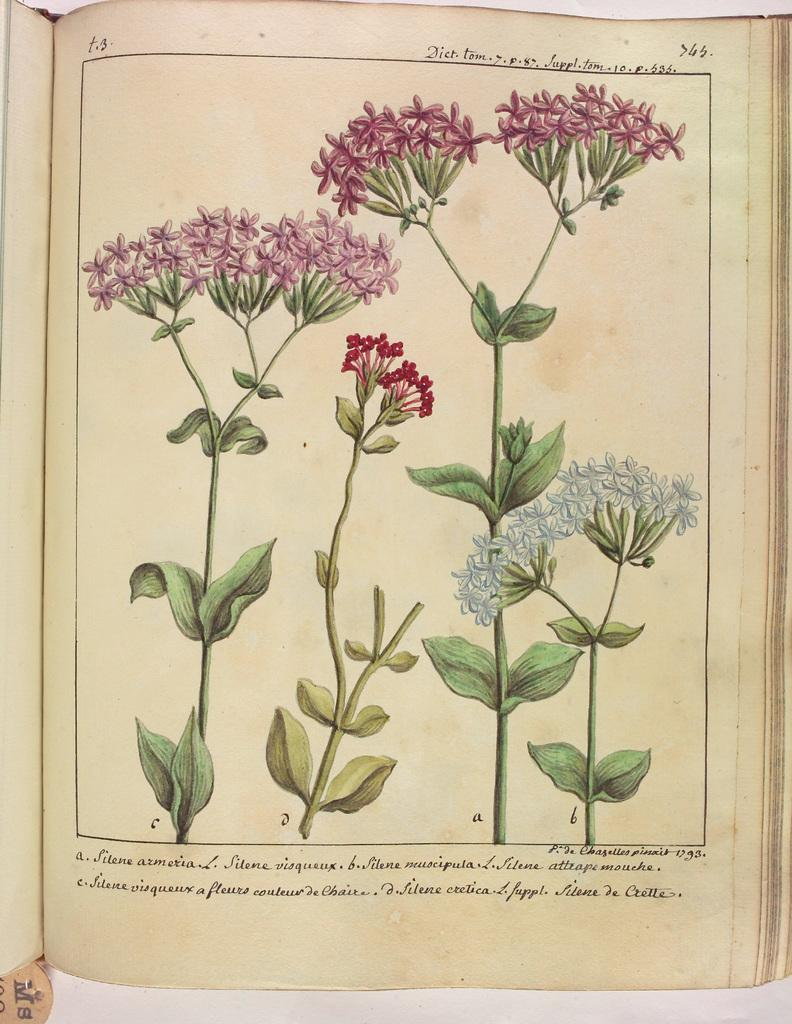What is the medium of the image? The image might be a painting in a book. What is the state of the book in the image? The book is opened. What type of plant can be seen in the image? There is a plant with flowers in the image. Can you describe the plough that is being used to cultivate the flowers in the image? There is no plough present in the image; it features a painting of a plant with flowers in a book. What type of cave can be seen in the background of the image? There is no cave present in the image; it features a painting of a plant with flowers in a book. 